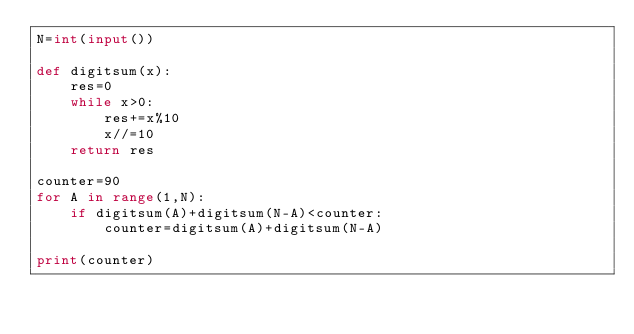Convert code to text. <code><loc_0><loc_0><loc_500><loc_500><_Python_>N=int(input())

def digitsum(x):
    res=0
    while x>0:
        res+=x%10
        x//=10
    return res

counter=90
for A in range(1,N):
    if digitsum(A)+digitsum(N-A)<counter:
        counter=digitsum(A)+digitsum(N-A)

print(counter)
</code> 